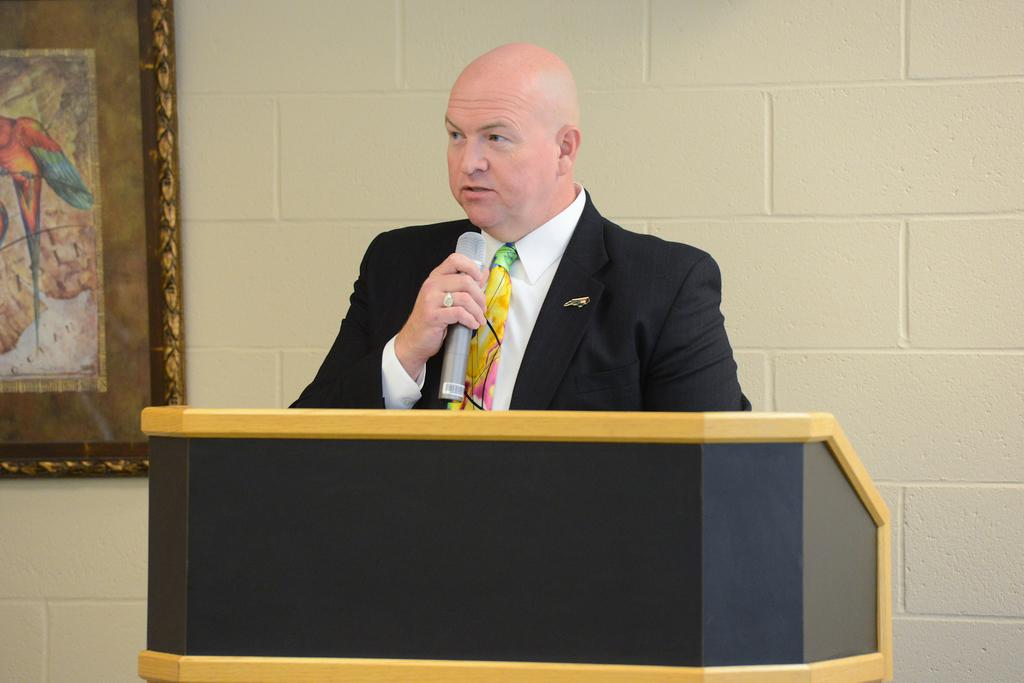What is the person in the image doing? The person is standing with a mic in the image. Where is the person located in the image? The person is at a desk. What can be seen in the background of the image? There is a wall and a photo frame in the background of the image. What type of yak is depicted in the photo frame in the image? There is no yak present in the image, and the photo frame does not depict any animals. 